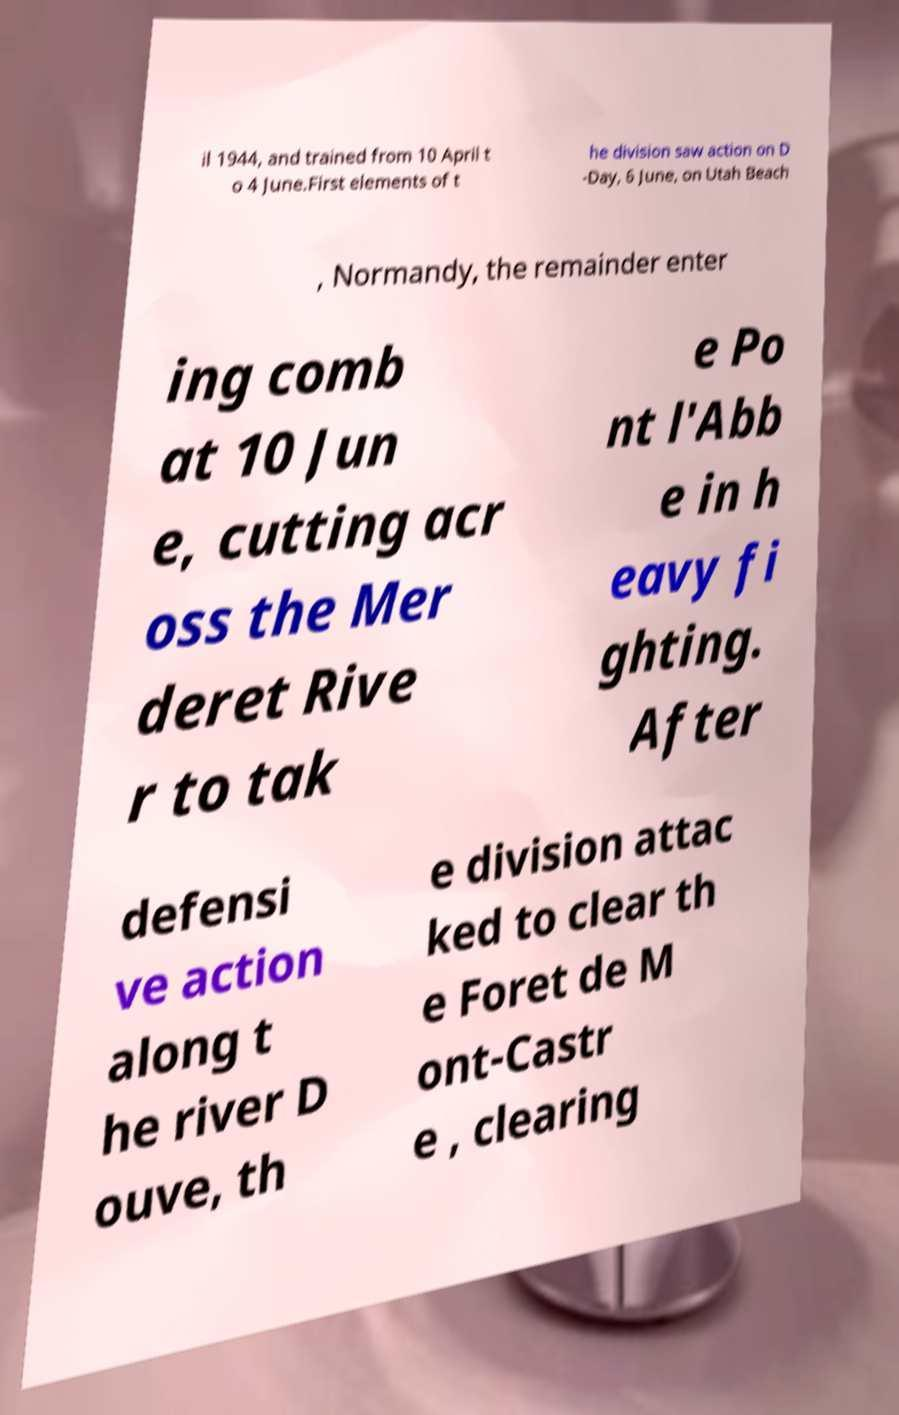What messages or text are displayed in this image? I need them in a readable, typed format. il 1944, and trained from 10 April t o 4 June.First elements of t he division saw action on D -Day, 6 June, on Utah Beach , Normandy, the remainder enter ing comb at 10 Jun e, cutting acr oss the Mer deret Rive r to tak e Po nt l'Abb e in h eavy fi ghting. After defensi ve action along t he river D ouve, th e division attac ked to clear th e Foret de M ont-Castr e , clearing 